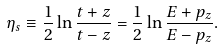Convert formula to latex. <formula><loc_0><loc_0><loc_500><loc_500>\eta _ { s } \equiv \frac { 1 } { 2 } \ln \frac { t + z } { t - z } = \frac { 1 } { 2 } \ln \frac { E + p _ { z } } { E - p _ { z } } .</formula> 